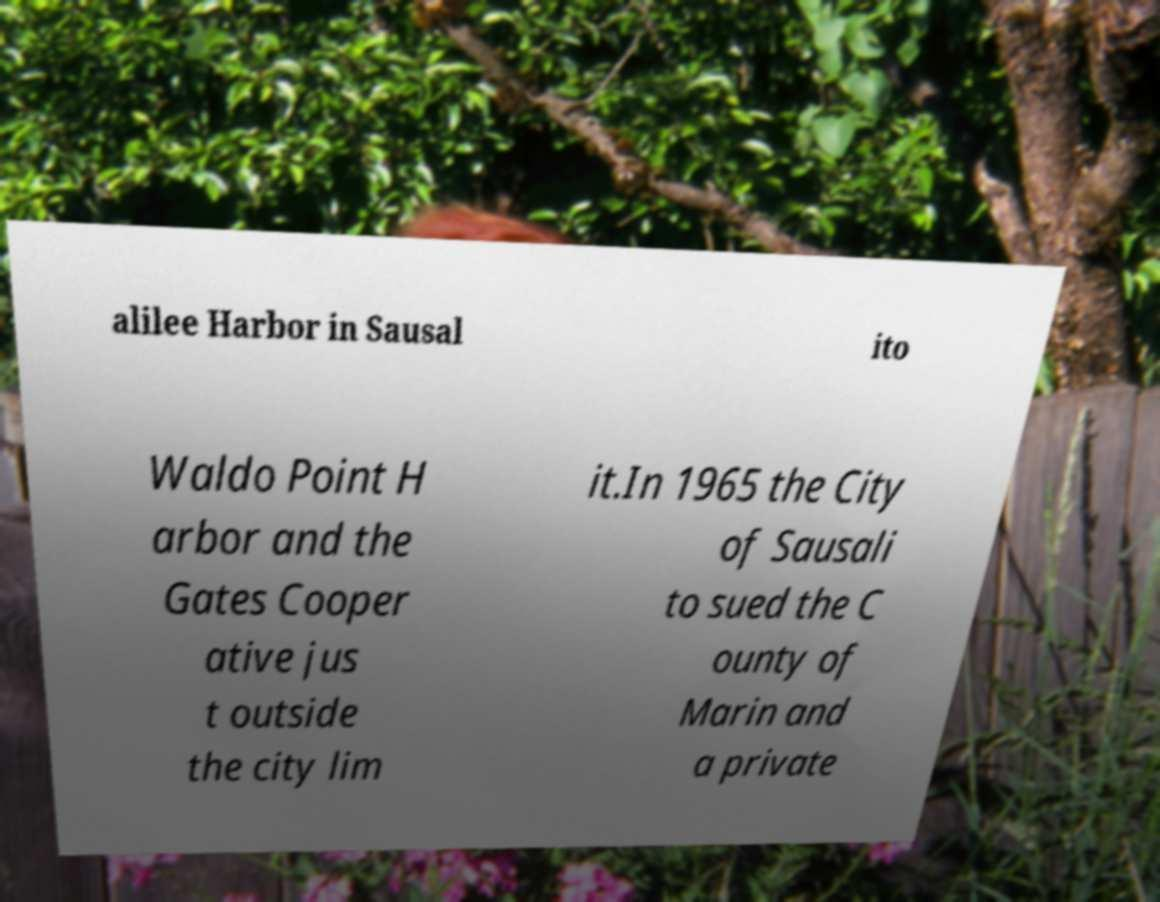Can you read and provide the text displayed in the image?This photo seems to have some interesting text. Can you extract and type it out for me? alilee Harbor in Sausal ito Waldo Point H arbor and the Gates Cooper ative jus t outside the city lim it.In 1965 the City of Sausali to sued the C ounty of Marin and a private 